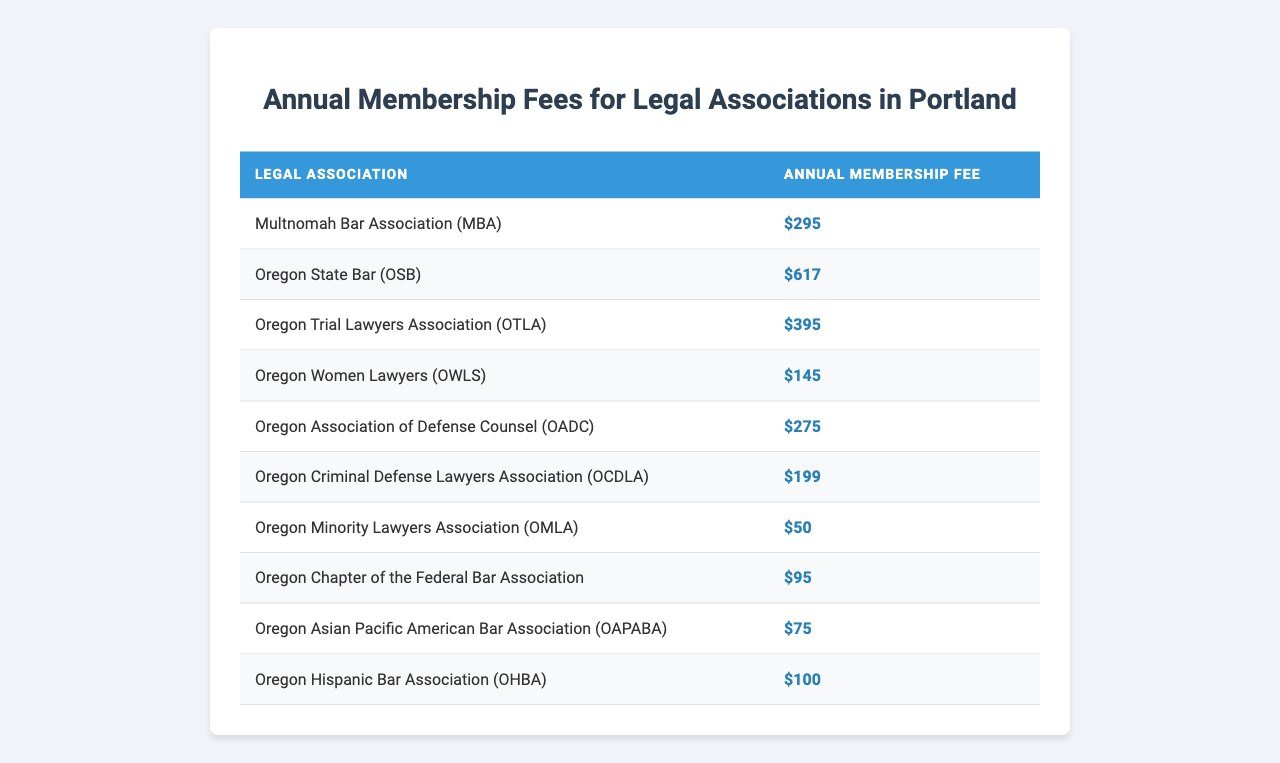What is the membership fee for the Multnomah Bar Association? The membership fee for the Multnomah Bar Association is listed directly in the table. It shows "$295" under the corresponding row.
Answer: $295 Which legal association has the highest annual membership fee? To determine the highest fee, I compare all membership fees in the table. The Oregon State Bar has the highest fee at "$617."
Answer: Oregon State Bar (OSB) Is the membership fee for the Oregon Criminal Defense Lawyers Association more than $200? The fee for the Oregon Criminal Defense Lawyers Association is "$199," which is less than $200.
Answer: No What is the total membership fee for the Oregon Women Lawyers and the Oregon Hispanic Bar Association? To find the total, I add the membership fees: $145 (for OWLS) + $100 (for OHBA) = $245.
Answer: $245 Which legal associations have membership fees less than $100? I examine each fee in the table: the Oregon Minority Lawyers Association ($50), Oregon Asian Pacific American Bar Association ($75), and Oregon Hispanic Bar Association ($100) don't exceed $100. The only two associations with fees under $100 are the Oregon Minority Lawyers Association and the Oregon Asian Pacific American Bar Association.
Answer: Oregon Minority Lawyers Association, Oregon Asian Pacific American Bar Association What is the difference in membership fees between the highest and lowest associations? The highest fee is from the Oregon State Bar ($617) and the lowest is from the Oregon Minority Lawyers Association ($50). The difference is $617 - $50 = $567.
Answer: $567 How many associations have membership fees of $200 or less? I look through the table and find fees of $199 (OCDLA), $145 (OWLS), $100 (OHBA), $75 (OAPABA), and $50 (OMLA) for a total of 5 associations with fees of $200 or less.
Answer: 5 Which associations have fees greater than the membership fee of the Multnomah Bar Association? I compare the fees: the Oregon State Bar ($617), Oregon Trial Lawyers Association ($395), and Oregon Association of Defense Counsel ($275) all exceed $295.
Answer: Oregon State Bar, Oregon Trial Lawyers Association, Oregon Association of Defense Counsel What is the average membership fee of all the listed legal associations? I sum the fees: $295 + $617 + $395 + $145 + $275 + $199 + $50 + $95 + $75 + $100 = $2,351. There are 10 associations, so the average is $2,351 / 10 = $235.10.
Answer: $235.10 Is there only one association that charges a fee of $145? Upon reviewing the table, I see that only the Oregon Women Lawyers association lists a fee of $145, confirming that it is unique.
Answer: Yes 